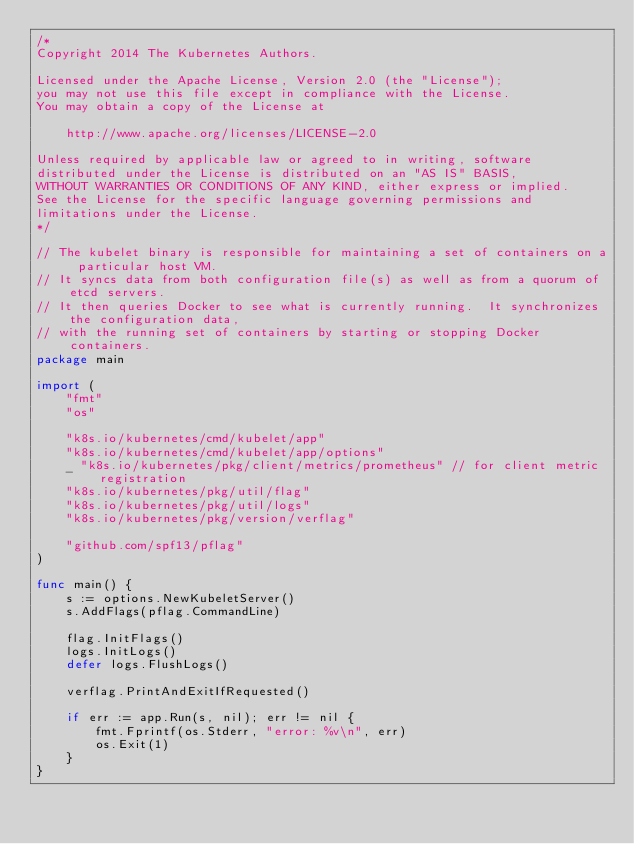<code> <loc_0><loc_0><loc_500><loc_500><_Go_>/*
Copyright 2014 The Kubernetes Authors.

Licensed under the Apache License, Version 2.0 (the "License");
you may not use this file except in compliance with the License.
You may obtain a copy of the License at

    http://www.apache.org/licenses/LICENSE-2.0

Unless required by applicable law or agreed to in writing, software
distributed under the License is distributed on an "AS IS" BASIS,
WITHOUT WARRANTIES OR CONDITIONS OF ANY KIND, either express or implied.
See the License for the specific language governing permissions and
limitations under the License.
*/

// The kubelet binary is responsible for maintaining a set of containers on a particular host VM.
// It syncs data from both configuration file(s) as well as from a quorum of etcd servers.
// It then queries Docker to see what is currently running.  It synchronizes the configuration data,
// with the running set of containers by starting or stopping Docker containers.
package main

import (
	"fmt"
	"os"

	"k8s.io/kubernetes/cmd/kubelet/app"
	"k8s.io/kubernetes/cmd/kubelet/app/options"
	_ "k8s.io/kubernetes/pkg/client/metrics/prometheus" // for client metric registration
	"k8s.io/kubernetes/pkg/util/flag"
	"k8s.io/kubernetes/pkg/util/logs"
	"k8s.io/kubernetes/pkg/version/verflag"

	"github.com/spf13/pflag"
)

func main() {
	s := options.NewKubeletServer()
	s.AddFlags(pflag.CommandLine)

	flag.InitFlags()
	logs.InitLogs()
	defer logs.FlushLogs()

	verflag.PrintAndExitIfRequested()

	if err := app.Run(s, nil); err != nil {
		fmt.Fprintf(os.Stderr, "error: %v\n", err)
		os.Exit(1)
	}
}
</code> 